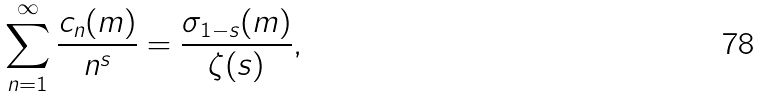Convert formula to latex. <formula><loc_0><loc_0><loc_500><loc_500>\sum _ { n = 1 } ^ { \infty } \frac { c _ { n } ( m ) } { n ^ { s } } = \frac { \sigma _ { 1 - s } ( m ) } { \zeta ( s ) } ,</formula> 